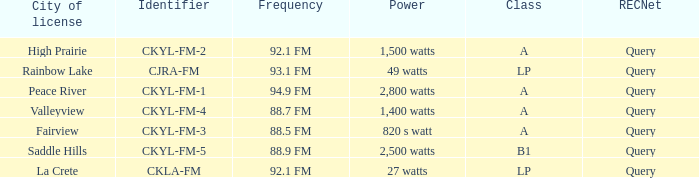What is the frequency that has a fairview city of license 88.5 FM. 